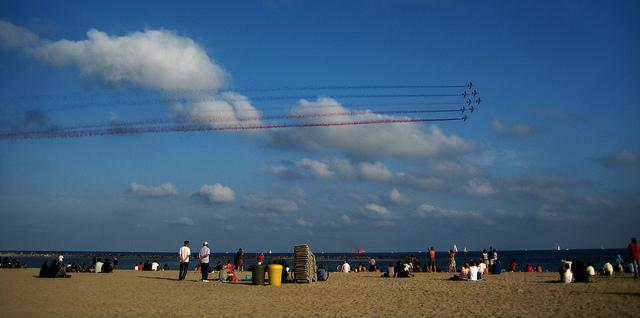How many colors are ejected from the planes flying in formation? five 